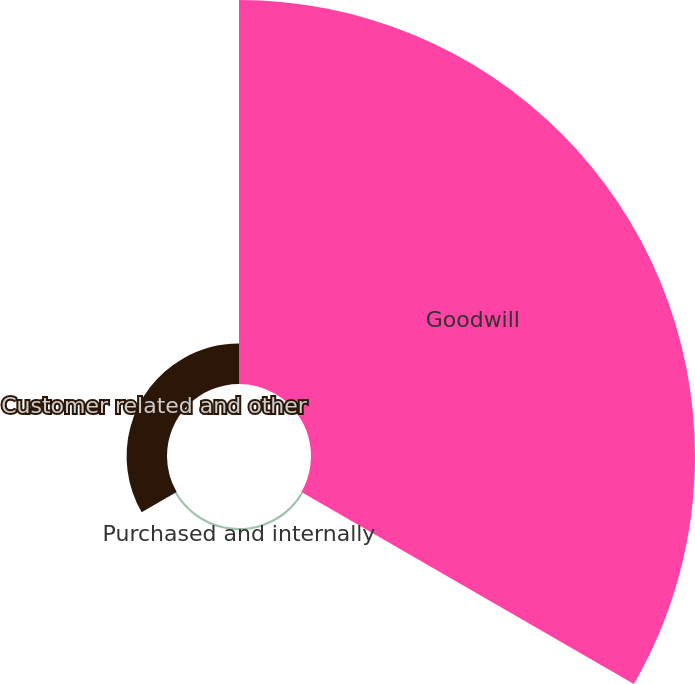Convert chart. <chart><loc_0><loc_0><loc_500><loc_500><pie_chart><fcel>Goodwill<fcel>Purchased and internally<fcel>Customer related and other<nl><fcel>90.01%<fcel>0.52%<fcel>9.47%<nl></chart> 